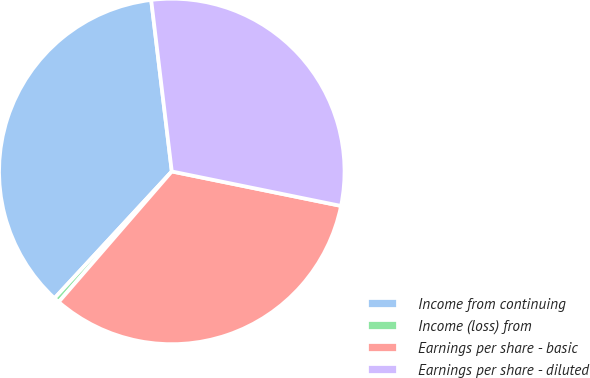<chart> <loc_0><loc_0><loc_500><loc_500><pie_chart><fcel>Income from continuing<fcel>Income (loss) from<fcel>Earnings per share - basic<fcel>Earnings per share - diluted<nl><fcel>36.21%<fcel>0.52%<fcel>33.16%<fcel>30.1%<nl></chart> 